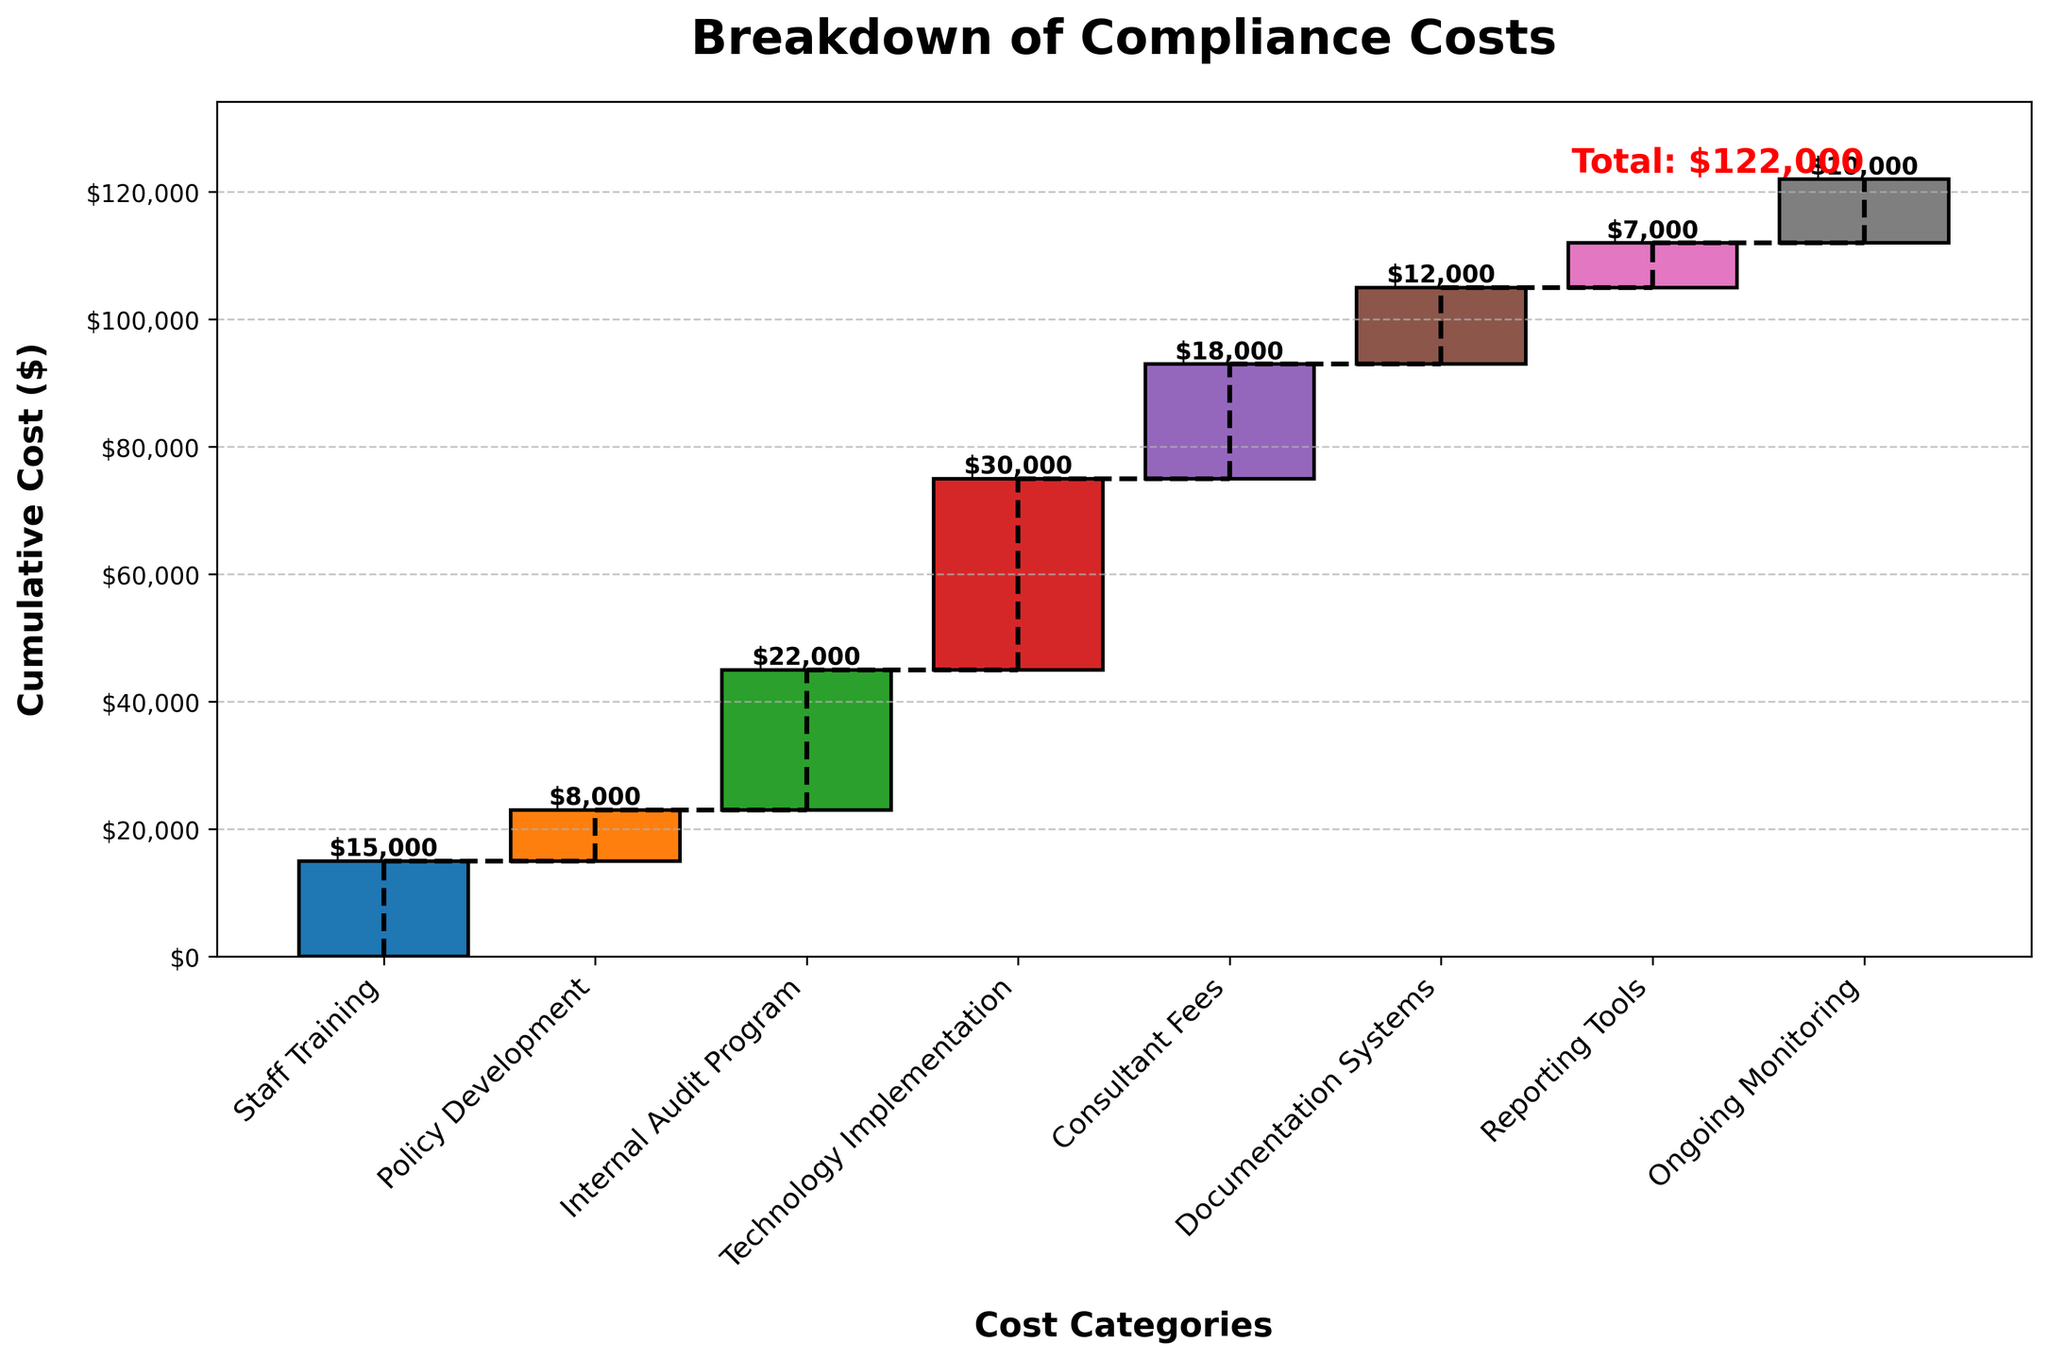What's the total cost of compliance? The total cost is shown at the end of the chart, summed up from all the individual categories. It is marked with "Total: $122,000" at the top of the last bar.
Answer: $122,000 Which category has the highest compliance cost? By looking at the height of each bar, the "Technology Implementation" category has the highest value.
Answer: Technology Implementation What's the cumulative cost after "Internal Audit Program"? To find the cumulative cost after "Internal Audit Program", add the costs from "Staff Training" to "Internal Audit Program": $15,000 + $8,000 + $22,000 = $45,000.
Answer: $45,000 How much more was spent on "Technology Implementation" compared to "Consultant Fees"? Subtract the cost of "Consultant Fees" from "Technology Implementation": $30,000 - $18,000 = $12,000.
Answer: $12,000 What's the most significant contributor to the total compliance costs besides "Technology Implementation"? Excluding "Technology Implementation", the next highest bar is "Internal Audit Program" with a value of $22,000.
Answer: Internal Audit Program If "Ongoing Monitoring" cost is increased by 50%, what will be the new total compliance cost? First, calculate 50% of "Ongoing Monitoring": $10,000 * 0.5 = $5,000. Add this to the original total: $122,000 + $5,000 = $127,000.
Answer: $127,000 What's the average cost per category? Divide the total cost by the number of categories: $122,000 / 8 = $15,250.
Answer: $15,250 By how much did the cost increase from "Policy Development" to "Internal Audit Program"? Subtract the cost of "Policy Development" from "Internal Audit Program": $22,000 - $8,000 = $14,000.
Answer: $14,000 Which categories fall below the overall average cost? The average cost per category is $15,250. The categories below this cost are "Policy Development", "Documentation Systems", and "Reporting Tools".
Answer: Policy Development, Documentation Systems, Reporting Tools What is the total cost contributed by "Documentation Systems" and "Reporting Tools" combined? Add the costs of "Documentation Systems" and "Reporting Tools": $12,000 + $7,000 = $19,000.
Answer: $19,000 